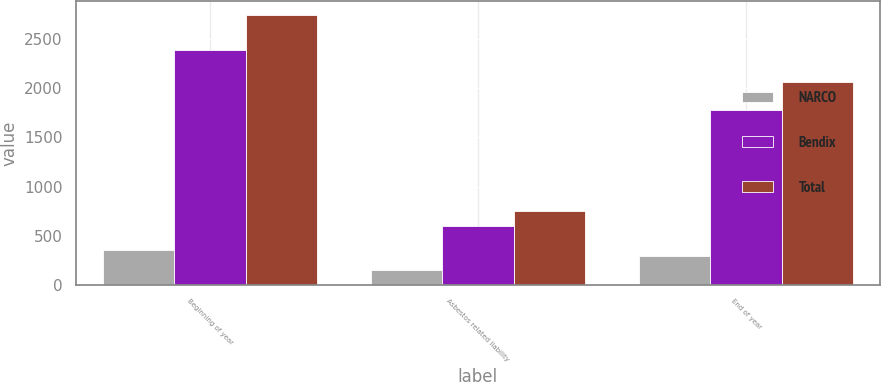<chart> <loc_0><loc_0><loc_500><loc_500><stacked_bar_chart><ecel><fcel>Beginning of year<fcel>Asbestos related liability<fcel>End of year<nl><fcel>NARCO<fcel>355<fcel>153<fcel>287<nl><fcel>Bendix<fcel>2395<fcel>597<fcel>1782<nl><fcel>Total<fcel>2750<fcel>750<fcel>2069<nl></chart> 